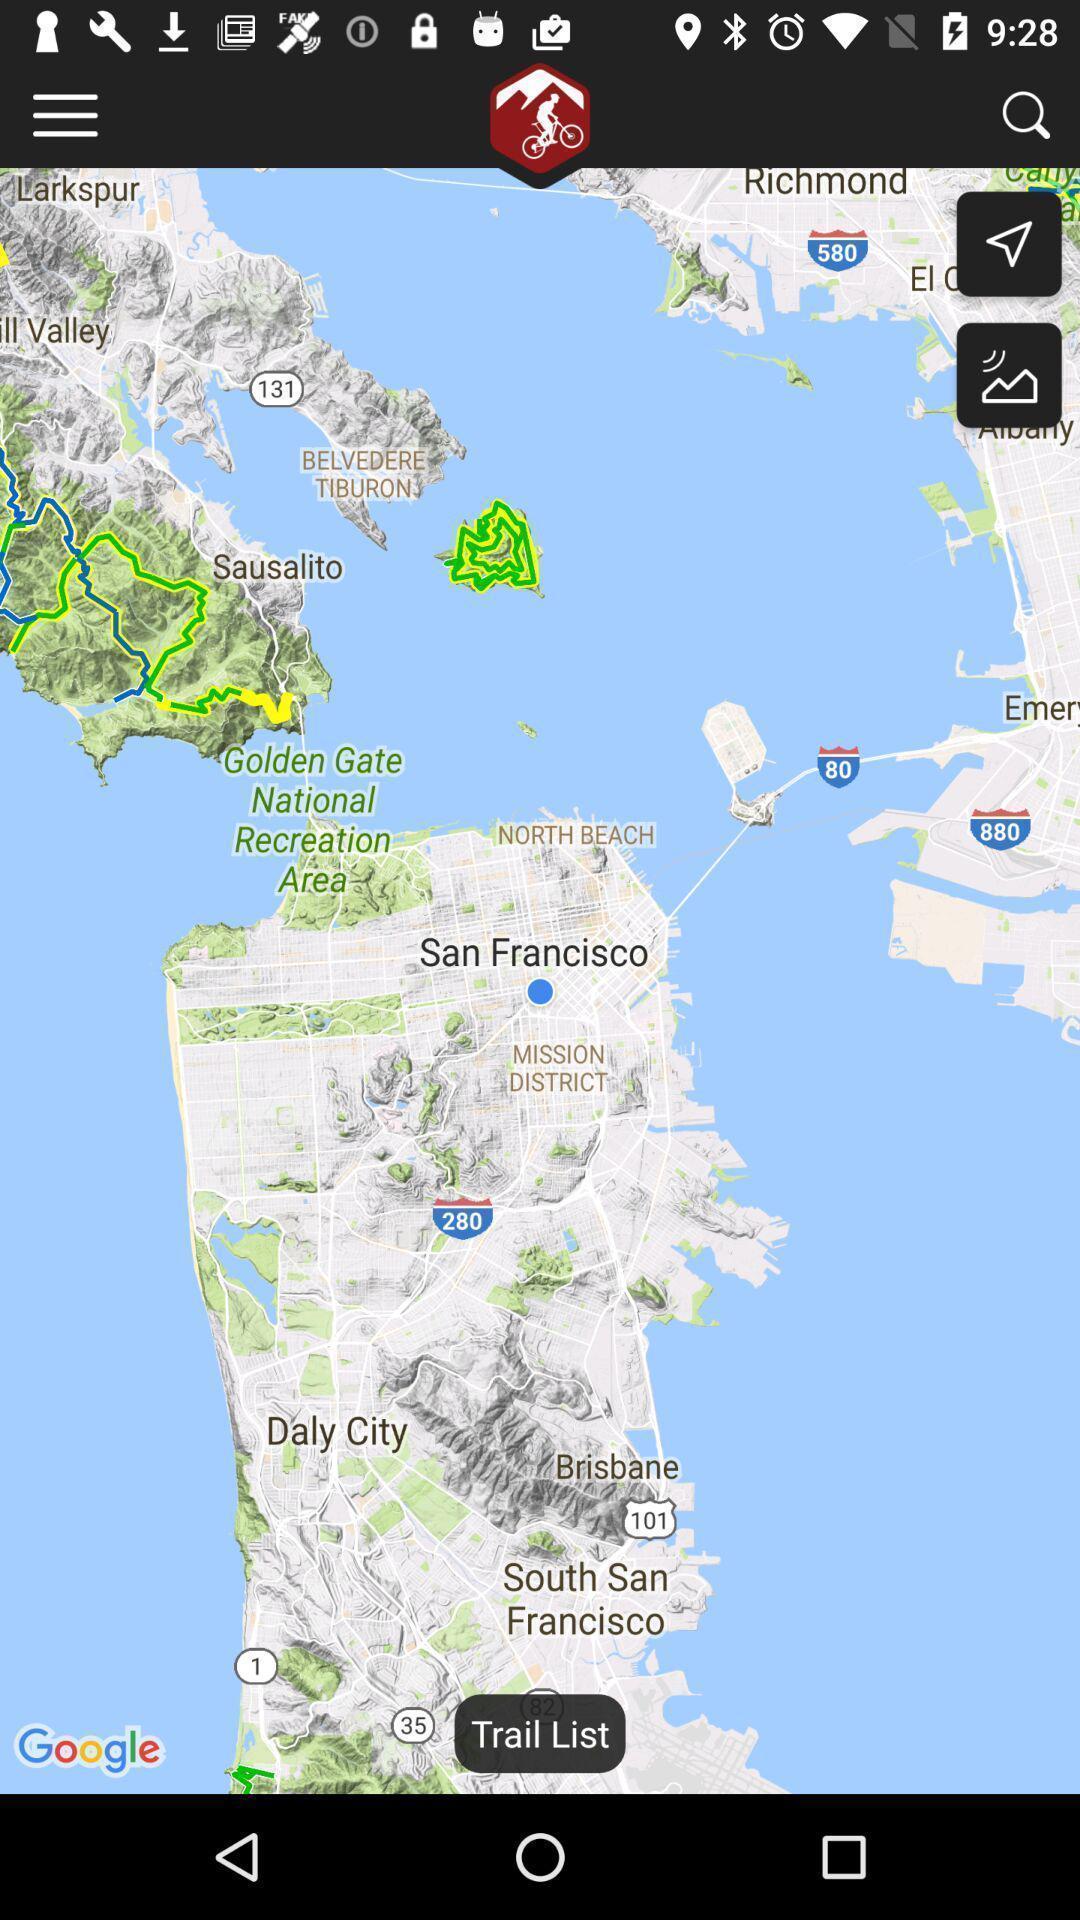Tell me about the visual elements in this screen capture. Phone map satellite view of cities. 